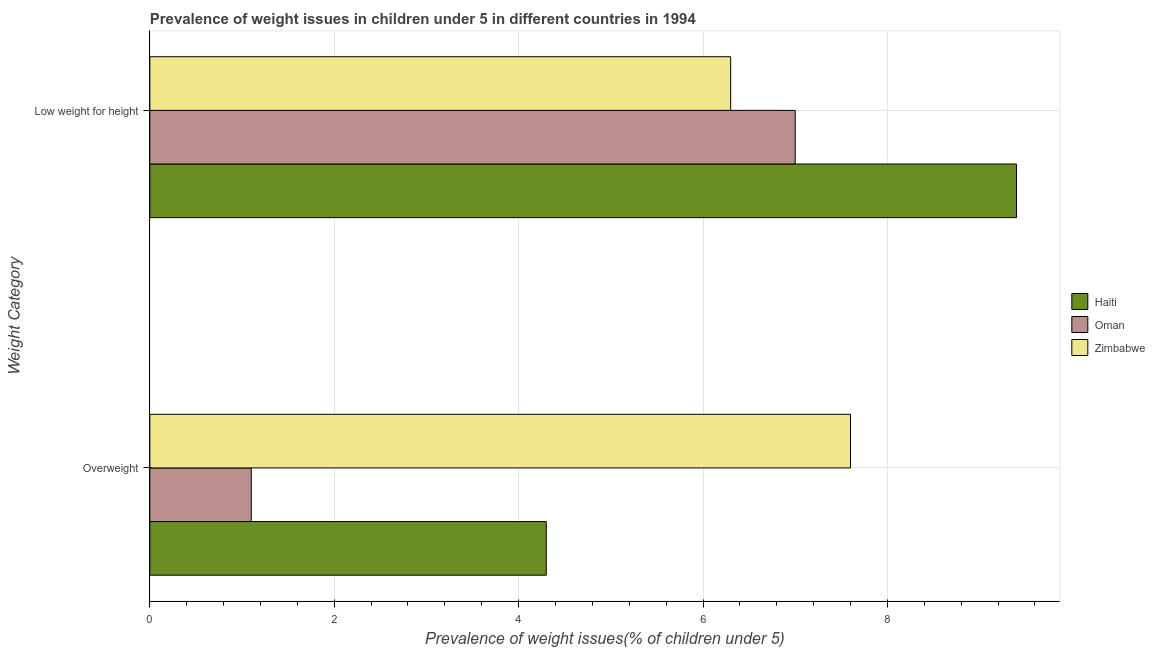How many different coloured bars are there?
Provide a short and direct response. 3. How many groups of bars are there?
Provide a short and direct response. 2. Are the number of bars per tick equal to the number of legend labels?
Keep it short and to the point. Yes. What is the label of the 1st group of bars from the top?
Make the answer very short. Low weight for height. What is the percentage of overweight children in Zimbabwe?
Your answer should be compact. 7.6. Across all countries, what is the maximum percentage of underweight children?
Ensure brevity in your answer.  9.4. Across all countries, what is the minimum percentage of overweight children?
Ensure brevity in your answer.  1.1. In which country was the percentage of overweight children maximum?
Make the answer very short. Zimbabwe. In which country was the percentage of underweight children minimum?
Keep it short and to the point. Zimbabwe. What is the total percentage of underweight children in the graph?
Keep it short and to the point. 22.7. What is the difference between the percentage of underweight children in Oman and that in Haiti?
Provide a succinct answer. -2.4. What is the difference between the percentage of underweight children in Haiti and the percentage of overweight children in Zimbabwe?
Offer a terse response. 1.8. What is the average percentage of overweight children per country?
Make the answer very short. 4.33. What is the difference between the percentage of overweight children and percentage of underweight children in Haiti?
Ensure brevity in your answer.  -5.1. In how many countries, is the percentage of overweight children greater than 8.8 %?
Provide a short and direct response. 0. What is the ratio of the percentage of underweight children in Haiti to that in Oman?
Provide a short and direct response. 1.34. What does the 2nd bar from the top in Overweight represents?
Your answer should be compact. Oman. What does the 3rd bar from the bottom in Low weight for height represents?
Offer a very short reply. Zimbabwe. How many bars are there?
Make the answer very short. 6. Are the values on the major ticks of X-axis written in scientific E-notation?
Ensure brevity in your answer.  No. Does the graph contain any zero values?
Provide a succinct answer. No. Does the graph contain grids?
Your answer should be very brief. Yes. How are the legend labels stacked?
Give a very brief answer. Vertical. What is the title of the graph?
Ensure brevity in your answer.  Prevalence of weight issues in children under 5 in different countries in 1994. Does "Namibia" appear as one of the legend labels in the graph?
Provide a short and direct response. No. What is the label or title of the X-axis?
Your response must be concise. Prevalence of weight issues(% of children under 5). What is the label or title of the Y-axis?
Give a very brief answer. Weight Category. What is the Prevalence of weight issues(% of children under 5) in Haiti in Overweight?
Ensure brevity in your answer.  4.3. What is the Prevalence of weight issues(% of children under 5) of Oman in Overweight?
Offer a terse response. 1.1. What is the Prevalence of weight issues(% of children under 5) of Zimbabwe in Overweight?
Provide a succinct answer. 7.6. What is the Prevalence of weight issues(% of children under 5) of Haiti in Low weight for height?
Provide a short and direct response. 9.4. What is the Prevalence of weight issues(% of children under 5) of Zimbabwe in Low weight for height?
Ensure brevity in your answer.  6.3. Across all Weight Category, what is the maximum Prevalence of weight issues(% of children under 5) of Haiti?
Ensure brevity in your answer.  9.4. Across all Weight Category, what is the maximum Prevalence of weight issues(% of children under 5) in Oman?
Your answer should be compact. 7. Across all Weight Category, what is the maximum Prevalence of weight issues(% of children under 5) of Zimbabwe?
Offer a terse response. 7.6. Across all Weight Category, what is the minimum Prevalence of weight issues(% of children under 5) of Haiti?
Ensure brevity in your answer.  4.3. Across all Weight Category, what is the minimum Prevalence of weight issues(% of children under 5) of Oman?
Your response must be concise. 1.1. Across all Weight Category, what is the minimum Prevalence of weight issues(% of children under 5) in Zimbabwe?
Offer a very short reply. 6.3. What is the total Prevalence of weight issues(% of children under 5) of Haiti in the graph?
Your response must be concise. 13.7. What is the difference between the Prevalence of weight issues(% of children under 5) of Zimbabwe in Overweight and that in Low weight for height?
Make the answer very short. 1.3. What is the difference between the Prevalence of weight issues(% of children under 5) of Oman in Overweight and the Prevalence of weight issues(% of children under 5) of Zimbabwe in Low weight for height?
Your response must be concise. -5.2. What is the average Prevalence of weight issues(% of children under 5) of Haiti per Weight Category?
Provide a short and direct response. 6.85. What is the average Prevalence of weight issues(% of children under 5) in Oman per Weight Category?
Provide a short and direct response. 4.05. What is the average Prevalence of weight issues(% of children under 5) of Zimbabwe per Weight Category?
Offer a very short reply. 6.95. What is the difference between the Prevalence of weight issues(% of children under 5) of Haiti and Prevalence of weight issues(% of children under 5) of Oman in Overweight?
Provide a succinct answer. 3.2. What is the difference between the Prevalence of weight issues(% of children under 5) in Oman and Prevalence of weight issues(% of children under 5) in Zimbabwe in Low weight for height?
Your response must be concise. 0.7. What is the ratio of the Prevalence of weight issues(% of children under 5) in Haiti in Overweight to that in Low weight for height?
Offer a very short reply. 0.46. What is the ratio of the Prevalence of weight issues(% of children under 5) in Oman in Overweight to that in Low weight for height?
Make the answer very short. 0.16. What is the ratio of the Prevalence of weight issues(% of children under 5) in Zimbabwe in Overweight to that in Low weight for height?
Make the answer very short. 1.21. What is the difference between the highest and the second highest Prevalence of weight issues(% of children under 5) of Oman?
Provide a short and direct response. 5.9. What is the difference between the highest and the second highest Prevalence of weight issues(% of children under 5) in Zimbabwe?
Ensure brevity in your answer.  1.3. What is the difference between the highest and the lowest Prevalence of weight issues(% of children under 5) of Haiti?
Offer a very short reply. 5.1. 